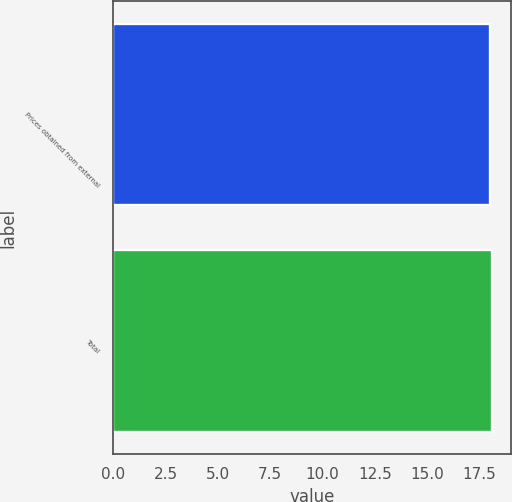<chart> <loc_0><loc_0><loc_500><loc_500><bar_chart><fcel>Prices obtained from external<fcel>Total<nl><fcel>18<fcel>18.1<nl></chart> 